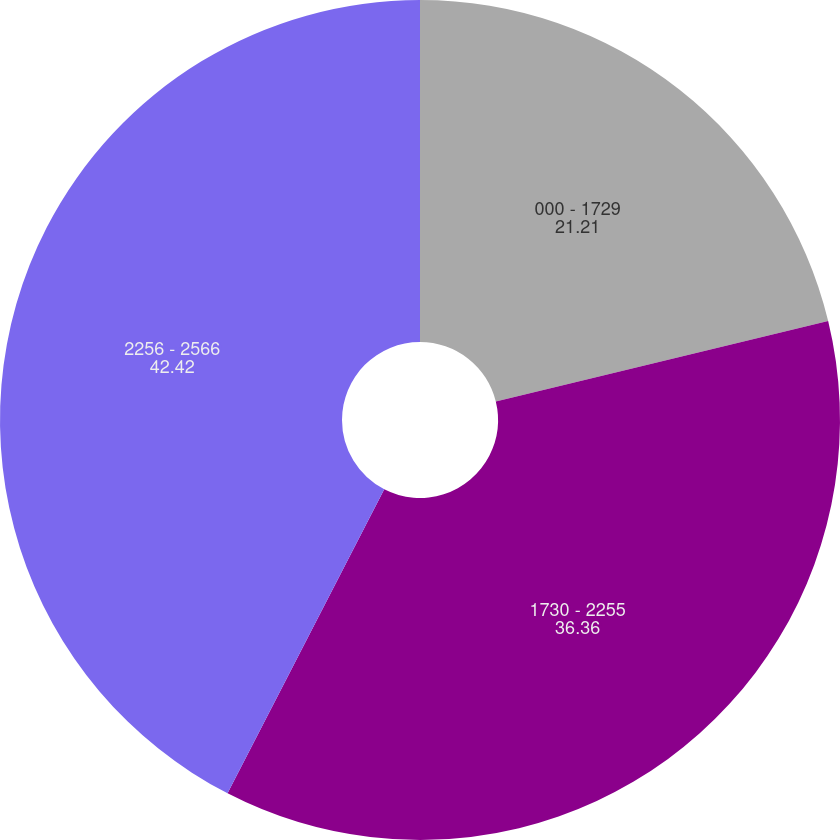Convert chart to OTSL. <chart><loc_0><loc_0><loc_500><loc_500><pie_chart><fcel>000 - 1729<fcel>1730 - 2255<fcel>2256 - 2566<nl><fcel>21.21%<fcel>36.36%<fcel>42.42%<nl></chart> 